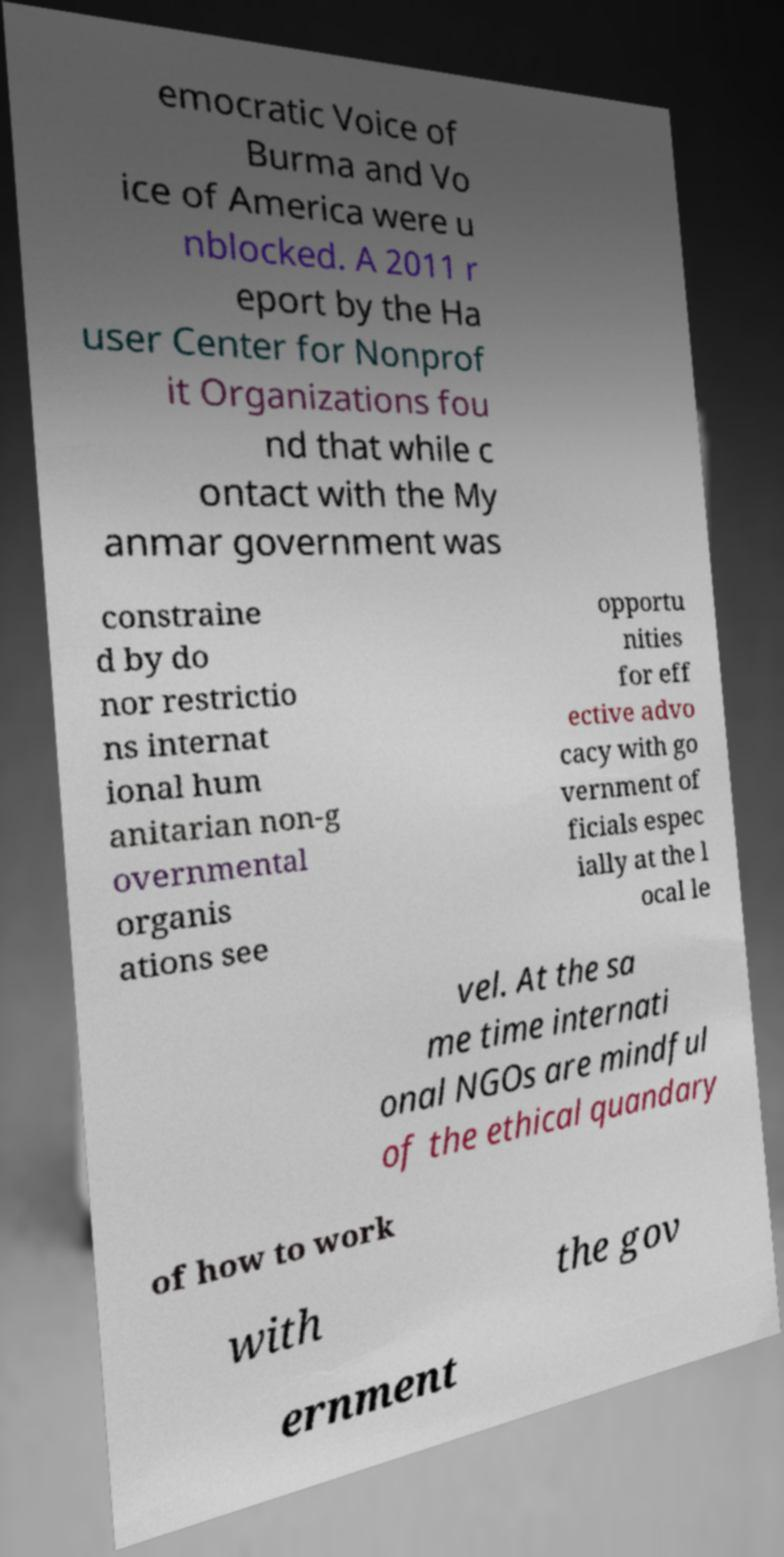Can you read and provide the text displayed in the image?This photo seems to have some interesting text. Can you extract and type it out for me? emocratic Voice of Burma and Vo ice of America were u nblocked. A 2011 r eport by the Ha user Center for Nonprof it Organizations fou nd that while c ontact with the My anmar government was constraine d by do nor restrictio ns internat ional hum anitarian non-g overnmental organis ations see opportu nities for eff ective advo cacy with go vernment of ficials espec ially at the l ocal le vel. At the sa me time internati onal NGOs are mindful of the ethical quandary of how to work with the gov ernment 